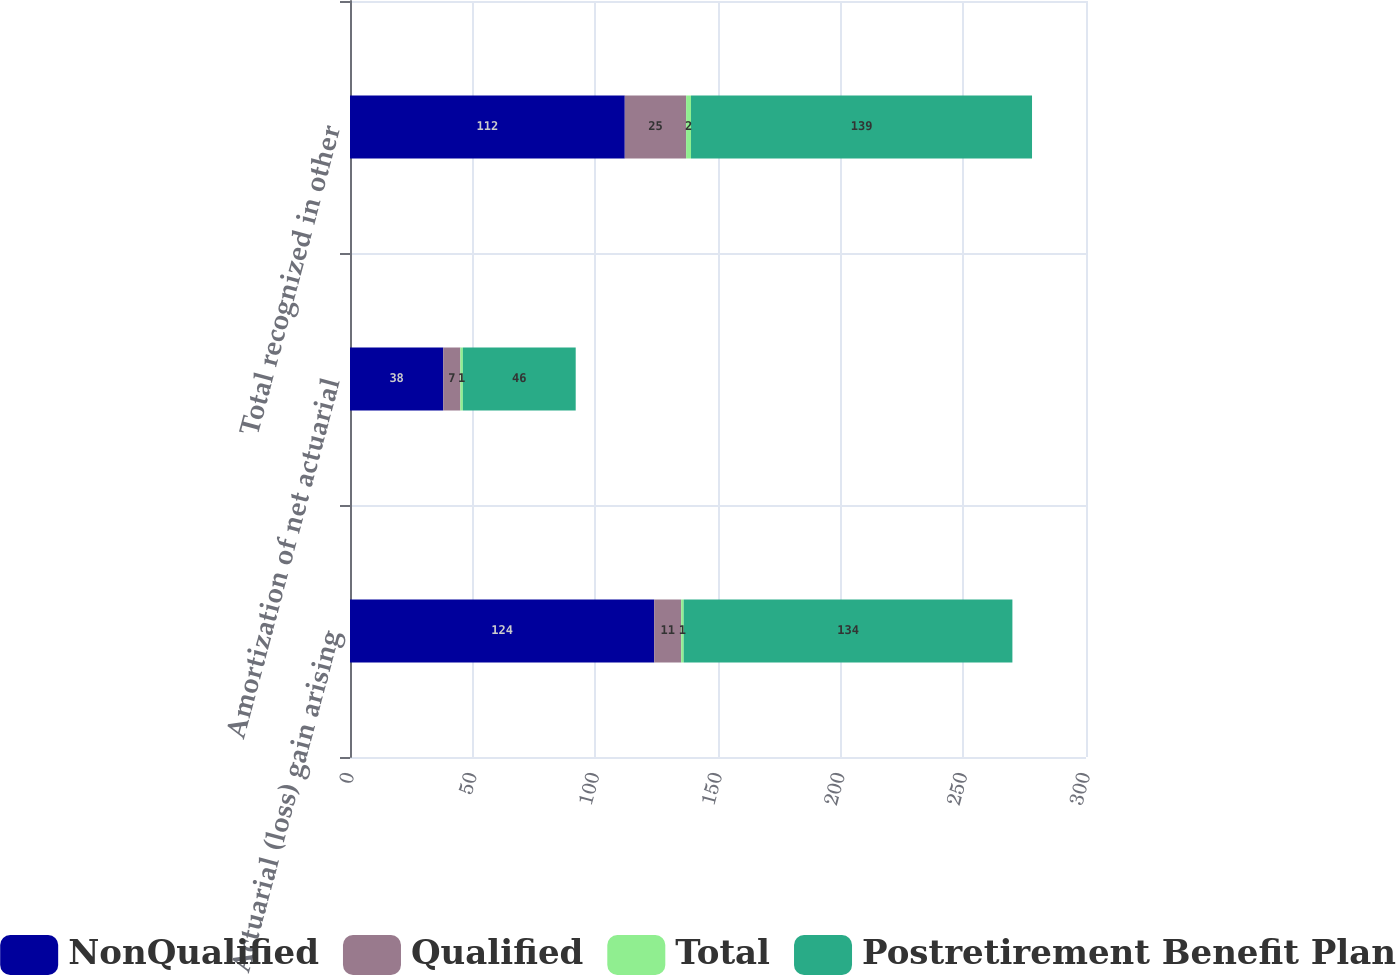<chart> <loc_0><loc_0><loc_500><loc_500><stacked_bar_chart><ecel><fcel>Actuarial (loss) gain arising<fcel>Amortization of net actuarial<fcel>Total recognized in other<nl><fcel>NonQualified<fcel>124<fcel>38<fcel>112<nl><fcel>Qualified<fcel>11<fcel>7<fcel>25<nl><fcel>Total<fcel>1<fcel>1<fcel>2<nl><fcel>Postretirement Benefit Plan<fcel>134<fcel>46<fcel>139<nl></chart> 